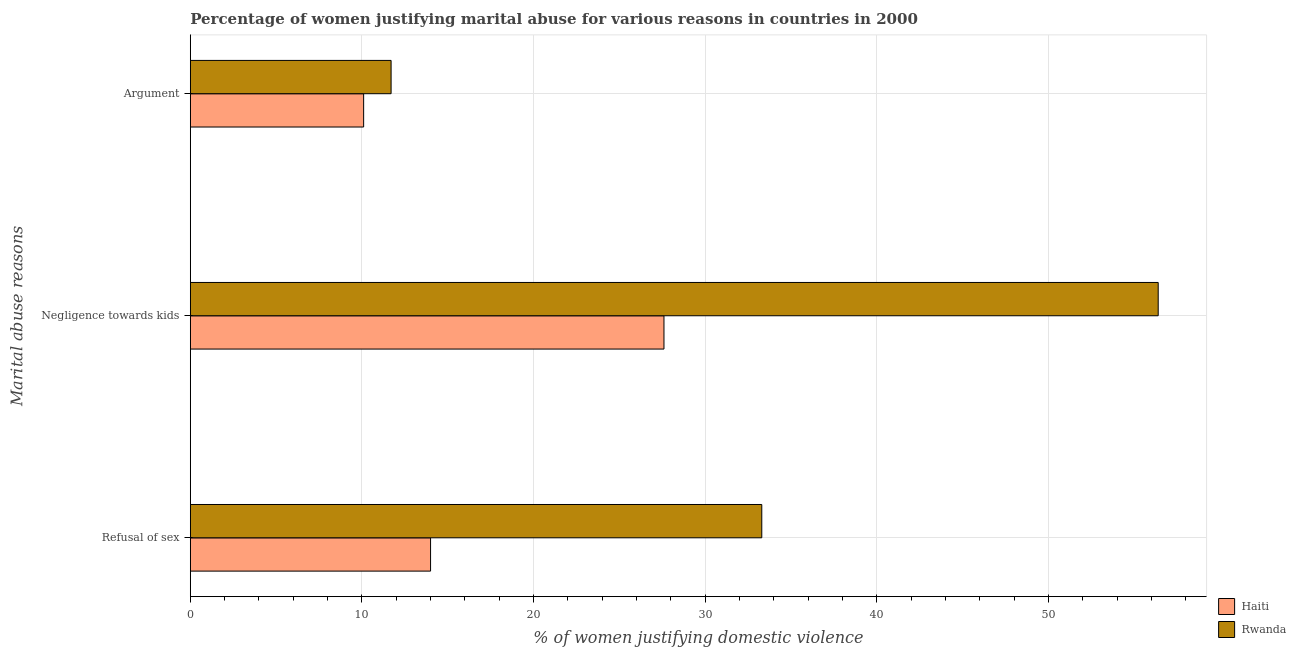What is the label of the 3rd group of bars from the top?
Provide a succinct answer. Refusal of sex. What is the percentage of women justifying domestic violence due to negligence towards kids in Haiti?
Offer a terse response. 27.6. Across all countries, what is the maximum percentage of women justifying domestic violence due to negligence towards kids?
Your response must be concise. 56.4. In which country was the percentage of women justifying domestic violence due to arguments maximum?
Provide a short and direct response. Rwanda. In which country was the percentage of women justifying domestic violence due to arguments minimum?
Keep it short and to the point. Haiti. What is the total percentage of women justifying domestic violence due to refusal of sex in the graph?
Offer a terse response. 47.3. What is the difference between the percentage of women justifying domestic violence due to arguments in Haiti and that in Rwanda?
Give a very brief answer. -1.6. What is the difference between the percentage of women justifying domestic violence due to arguments in Haiti and the percentage of women justifying domestic violence due to refusal of sex in Rwanda?
Ensure brevity in your answer.  -23.2. What is the average percentage of women justifying domestic violence due to arguments per country?
Make the answer very short. 10.9. What is the difference between the percentage of women justifying domestic violence due to arguments and percentage of women justifying domestic violence due to refusal of sex in Haiti?
Ensure brevity in your answer.  -3.9. What is the ratio of the percentage of women justifying domestic violence due to arguments in Rwanda to that in Haiti?
Your answer should be compact. 1.16. Is the percentage of women justifying domestic violence due to refusal of sex in Rwanda less than that in Haiti?
Give a very brief answer. No. What is the difference between the highest and the second highest percentage of women justifying domestic violence due to arguments?
Your answer should be compact. 1.6. What is the difference between the highest and the lowest percentage of women justifying domestic violence due to refusal of sex?
Your answer should be very brief. 19.3. What does the 2nd bar from the top in Negligence towards kids represents?
Make the answer very short. Haiti. What does the 1st bar from the bottom in Refusal of sex represents?
Make the answer very short. Haiti. How many bars are there?
Ensure brevity in your answer.  6. Are all the bars in the graph horizontal?
Give a very brief answer. Yes. What is the title of the graph?
Make the answer very short. Percentage of women justifying marital abuse for various reasons in countries in 2000. Does "Cambodia" appear as one of the legend labels in the graph?
Ensure brevity in your answer.  No. What is the label or title of the X-axis?
Give a very brief answer. % of women justifying domestic violence. What is the label or title of the Y-axis?
Provide a succinct answer. Marital abuse reasons. What is the % of women justifying domestic violence in Rwanda in Refusal of sex?
Your answer should be very brief. 33.3. What is the % of women justifying domestic violence of Haiti in Negligence towards kids?
Give a very brief answer. 27.6. What is the % of women justifying domestic violence of Rwanda in Negligence towards kids?
Your answer should be compact. 56.4. What is the % of women justifying domestic violence in Rwanda in Argument?
Provide a succinct answer. 11.7. Across all Marital abuse reasons, what is the maximum % of women justifying domestic violence of Haiti?
Offer a very short reply. 27.6. Across all Marital abuse reasons, what is the maximum % of women justifying domestic violence of Rwanda?
Your answer should be very brief. 56.4. Across all Marital abuse reasons, what is the minimum % of women justifying domestic violence of Rwanda?
Your answer should be compact. 11.7. What is the total % of women justifying domestic violence in Haiti in the graph?
Your response must be concise. 51.7. What is the total % of women justifying domestic violence of Rwanda in the graph?
Provide a short and direct response. 101.4. What is the difference between the % of women justifying domestic violence in Rwanda in Refusal of sex and that in Negligence towards kids?
Provide a short and direct response. -23.1. What is the difference between the % of women justifying domestic violence in Rwanda in Refusal of sex and that in Argument?
Provide a succinct answer. 21.6. What is the difference between the % of women justifying domestic violence of Rwanda in Negligence towards kids and that in Argument?
Your response must be concise. 44.7. What is the difference between the % of women justifying domestic violence in Haiti in Refusal of sex and the % of women justifying domestic violence in Rwanda in Negligence towards kids?
Offer a very short reply. -42.4. What is the difference between the % of women justifying domestic violence in Haiti in Refusal of sex and the % of women justifying domestic violence in Rwanda in Argument?
Provide a short and direct response. 2.3. What is the average % of women justifying domestic violence of Haiti per Marital abuse reasons?
Offer a very short reply. 17.23. What is the average % of women justifying domestic violence in Rwanda per Marital abuse reasons?
Keep it short and to the point. 33.8. What is the difference between the % of women justifying domestic violence of Haiti and % of women justifying domestic violence of Rwanda in Refusal of sex?
Ensure brevity in your answer.  -19.3. What is the difference between the % of women justifying domestic violence of Haiti and % of women justifying domestic violence of Rwanda in Negligence towards kids?
Your response must be concise. -28.8. What is the ratio of the % of women justifying domestic violence of Haiti in Refusal of sex to that in Negligence towards kids?
Make the answer very short. 0.51. What is the ratio of the % of women justifying domestic violence in Rwanda in Refusal of sex to that in Negligence towards kids?
Give a very brief answer. 0.59. What is the ratio of the % of women justifying domestic violence of Haiti in Refusal of sex to that in Argument?
Make the answer very short. 1.39. What is the ratio of the % of women justifying domestic violence in Rwanda in Refusal of sex to that in Argument?
Your answer should be very brief. 2.85. What is the ratio of the % of women justifying domestic violence of Haiti in Negligence towards kids to that in Argument?
Make the answer very short. 2.73. What is the ratio of the % of women justifying domestic violence of Rwanda in Negligence towards kids to that in Argument?
Give a very brief answer. 4.82. What is the difference between the highest and the second highest % of women justifying domestic violence in Rwanda?
Your answer should be compact. 23.1. What is the difference between the highest and the lowest % of women justifying domestic violence in Haiti?
Provide a short and direct response. 17.5. What is the difference between the highest and the lowest % of women justifying domestic violence in Rwanda?
Give a very brief answer. 44.7. 